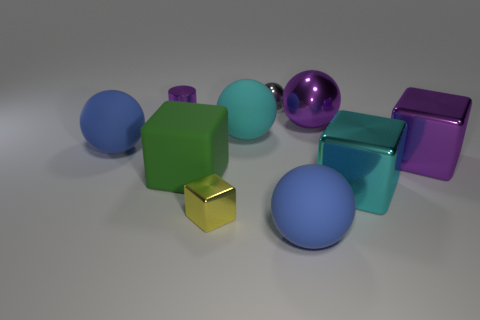What is the material of the cylinder that is the same color as the big metal ball?
Offer a very short reply. Metal. There is a metal cube behind the large green matte thing; does it have the same color as the tiny cylinder?
Make the answer very short. Yes. Is there a big shiny object of the same color as the cylinder?
Your response must be concise. Yes. There is a cylinder that is the same color as the big metal sphere; what is its size?
Ensure brevity in your answer.  Small. Is the color of the thing on the left side of the cylinder the same as the matte thing that is in front of the cyan shiny block?
Make the answer very short. Yes. What number of big metal cubes are there?
Your answer should be very brief. 2. There is a blue object that is behind the tiny yellow shiny thing; what shape is it?
Provide a succinct answer. Sphere. What number of other objects are there of the same size as the cyan sphere?
Your response must be concise. 6. There is a big blue matte object behind the green matte cube; is it the same shape as the purple metallic object that is behind the large purple ball?
Offer a terse response. No. There is a large cyan block; how many spheres are behind it?
Make the answer very short. 4. 